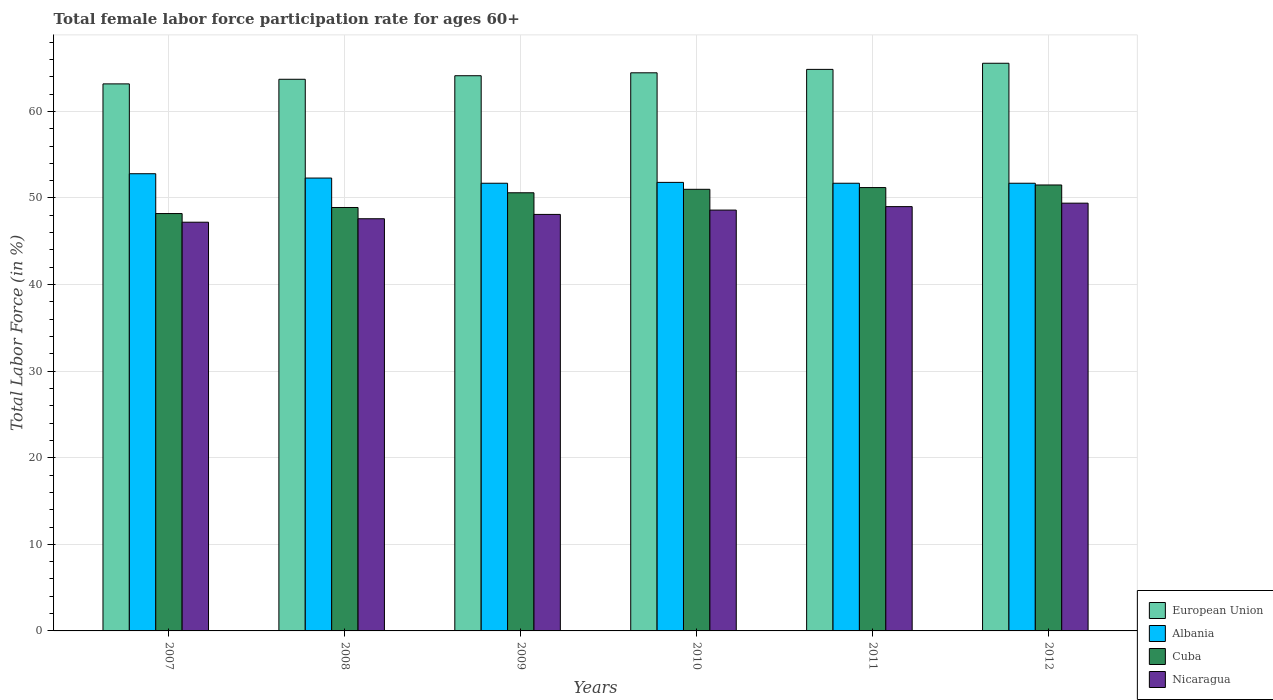Are the number of bars per tick equal to the number of legend labels?
Give a very brief answer. Yes. Are the number of bars on each tick of the X-axis equal?
Make the answer very short. Yes. How many bars are there on the 4th tick from the right?
Make the answer very short. 4. What is the label of the 1st group of bars from the left?
Your response must be concise. 2007. In how many cases, is the number of bars for a given year not equal to the number of legend labels?
Your answer should be compact. 0. What is the female labor force participation rate in Albania in 2009?
Ensure brevity in your answer.  51.7. Across all years, what is the maximum female labor force participation rate in Cuba?
Make the answer very short. 51.5. Across all years, what is the minimum female labor force participation rate in Albania?
Your answer should be compact. 51.7. In which year was the female labor force participation rate in Nicaragua maximum?
Give a very brief answer. 2012. What is the total female labor force participation rate in Nicaragua in the graph?
Provide a succinct answer. 289.9. What is the difference between the female labor force participation rate in Albania in 2008 and that in 2011?
Give a very brief answer. 0.6. What is the difference between the female labor force participation rate in Albania in 2007 and the female labor force participation rate in Cuba in 2008?
Your response must be concise. 3.9. What is the average female labor force participation rate in Cuba per year?
Offer a terse response. 50.23. In the year 2009, what is the difference between the female labor force participation rate in European Union and female labor force participation rate in Nicaragua?
Provide a succinct answer. 16.02. In how many years, is the female labor force participation rate in European Union greater than 28 %?
Offer a terse response. 6. What is the ratio of the female labor force participation rate in European Union in 2008 to that in 2011?
Offer a terse response. 0.98. Is the difference between the female labor force participation rate in European Union in 2010 and 2011 greater than the difference between the female labor force participation rate in Nicaragua in 2010 and 2011?
Make the answer very short. Yes. What is the difference between the highest and the second highest female labor force participation rate in Cuba?
Provide a succinct answer. 0.3. What is the difference between the highest and the lowest female labor force participation rate in Nicaragua?
Keep it short and to the point. 2.2. In how many years, is the female labor force participation rate in European Union greater than the average female labor force participation rate in European Union taken over all years?
Ensure brevity in your answer.  3. Is the sum of the female labor force participation rate in Albania in 2008 and 2012 greater than the maximum female labor force participation rate in European Union across all years?
Provide a short and direct response. Yes. Is it the case that in every year, the sum of the female labor force participation rate in Nicaragua and female labor force participation rate in Cuba is greater than the sum of female labor force participation rate in European Union and female labor force participation rate in Albania?
Your answer should be compact. No. What does the 1st bar from the left in 2007 represents?
Provide a succinct answer. European Union. Are all the bars in the graph horizontal?
Make the answer very short. No. How many years are there in the graph?
Make the answer very short. 6. Does the graph contain grids?
Your response must be concise. Yes. How are the legend labels stacked?
Provide a succinct answer. Vertical. What is the title of the graph?
Ensure brevity in your answer.  Total female labor force participation rate for ages 60+. Does "Bosnia and Herzegovina" appear as one of the legend labels in the graph?
Keep it short and to the point. No. What is the Total Labor Force (in %) of European Union in 2007?
Offer a terse response. 63.17. What is the Total Labor Force (in %) in Albania in 2007?
Provide a succinct answer. 52.8. What is the Total Labor Force (in %) of Cuba in 2007?
Your response must be concise. 48.2. What is the Total Labor Force (in %) in Nicaragua in 2007?
Provide a short and direct response. 47.2. What is the Total Labor Force (in %) of European Union in 2008?
Make the answer very short. 63.71. What is the Total Labor Force (in %) of Albania in 2008?
Give a very brief answer. 52.3. What is the Total Labor Force (in %) of Cuba in 2008?
Your answer should be very brief. 48.9. What is the Total Labor Force (in %) of Nicaragua in 2008?
Your response must be concise. 47.6. What is the Total Labor Force (in %) of European Union in 2009?
Offer a very short reply. 64.12. What is the Total Labor Force (in %) in Albania in 2009?
Provide a succinct answer. 51.7. What is the Total Labor Force (in %) in Cuba in 2009?
Ensure brevity in your answer.  50.6. What is the Total Labor Force (in %) of Nicaragua in 2009?
Your response must be concise. 48.1. What is the Total Labor Force (in %) of European Union in 2010?
Keep it short and to the point. 64.45. What is the Total Labor Force (in %) in Albania in 2010?
Your answer should be very brief. 51.8. What is the Total Labor Force (in %) of Nicaragua in 2010?
Make the answer very short. 48.6. What is the Total Labor Force (in %) of European Union in 2011?
Your answer should be very brief. 64.85. What is the Total Labor Force (in %) of Albania in 2011?
Give a very brief answer. 51.7. What is the Total Labor Force (in %) in Cuba in 2011?
Your answer should be very brief. 51.2. What is the Total Labor Force (in %) of Nicaragua in 2011?
Ensure brevity in your answer.  49. What is the Total Labor Force (in %) of European Union in 2012?
Keep it short and to the point. 65.56. What is the Total Labor Force (in %) in Albania in 2012?
Your answer should be compact. 51.7. What is the Total Labor Force (in %) in Cuba in 2012?
Give a very brief answer. 51.5. What is the Total Labor Force (in %) of Nicaragua in 2012?
Your response must be concise. 49.4. Across all years, what is the maximum Total Labor Force (in %) in European Union?
Your answer should be very brief. 65.56. Across all years, what is the maximum Total Labor Force (in %) in Albania?
Your response must be concise. 52.8. Across all years, what is the maximum Total Labor Force (in %) of Cuba?
Give a very brief answer. 51.5. Across all years, what is the maximum Total Labor Force (in %) in Nicaragua?
Ensure brevity in your answer.  49.4. Across all years, what is the minimum Total Labor Force (in %) in European Union?
Your answer should be very brief. 63.17. Across all years, what is the minimum Total Labor Force (in %) in Albania?
Offer a very short reply. 51.7. Across all years, what is the minimum Total Labor Force (in %) in Cuba?
Keep it short and to the point. 48.2. Across all years, what is the minimum Total Labor Force (in %) in Nicaragua?
Provide a short and direct response. 47.2. What is the total Total Labor Force (in %) of European Union in the graph?
Your answer should be compact. 385.86. What is the total Total Labor Force (in %) in Albania in the graph?
Your answer should be compact. 312. What is the total Total Labor Force (in %) of Cuba in the graph?
Provide a succinct answer. 301.4. What is the total Total Labor Force (in %) of Nicaragua in the graph?
Keep it short and to the point. 289.9. What is the difference between the Total Labor Force (in %) of European Union in 2007 and that in 2008?
Make the answer very short. -0.53. What is the difference between the Total Labor Force (in %) in Cuba in 2007 and that in 2008?
Your answer should be compact. -0.7. What is the difference between the Total Labor Force (in %) in Nicaragua in 2007 and that in 2008?
Ensure brevity in your answer.  -0.4. What is the difference between the Total Labor Force (in %) in European Union in 2007 and that in 2009?
Your response must be concise. -0.94. What is the difference between the Total Labor Force (in %) in Albania in 2007 and that in 2009?
Make the answer very short. 1.1. What is the difference between the Total Labor Force (in %) in Cuba in 2007 and that in 2009?
Offer a very short reply. -2.4. What is the difference between the Total Labor Force (in %) in Nicaragua in 2007 and that in 2009?
Give a very brief answer. -0.9. What is the difference between the Total Labor Force (in %) of European Union in 2007 and that in 2010?
Provide a short and direct response. -1.28. What is the difference between the Total Labor Force (in %) of Nicaragua in 2007 and that in 2010?
Ensure brevity in your answer.  -1.4. What is the difference between the Total Labor Force (in %) in European Union in 2007 and that in 2011?
Keep it short and to the point. -1.68. What is the difference between the Total Labor Force (in %) in Cuba in 2007 and that in 2011?
Offer a terse response. -3. What is the difference between the Total Labor Force (in %) of European Union in 2007 and that in 2012?
Your response must be concise. -2.38. What is the difference between the Total Labor Force (in %) in European Union in 2008 and that in 2009?
Ensure brevity in your answer.  -0.41. What is the difference between the Total Labor Force (in %) in Albania in 2008 and that in 2009?
Provide a short and direct response. 0.6. What is the difference between the Total Labor Force (in %) of Cuba in 2008 and that in 2009?
Your answer should be compact. -1.7. What is the difference between the Total Labor Force (in %) in European Union in 2008 and that in 2010?
Offer a very short reply. -0.75. What is the difference between the Total Labor Force (in %) of Nicaragua in 2008 and that in 2010?
Offer a terse response. -1. What is the difference between the Total Labor Force (in %) of European Union in 2008 and that in 2011?
Offer a terse response. -1.14. What is the difference between the Total Labor Force (in %) in Albania in 2008 and that in 2011?
Offer a terse response. 0.6. What is the difference between the Total Labor Force (in %) of European Union in 2008 and that in 2012?
Your answer should be very brief. -1.85. What is the difference between the Total Labor Force (in %) in Albania in 2008 and that in 2012?
Ensure brevity in your answer.  0.6. What is the difference between the Total Labor Force (in %) in Cuba in 2008 and that in 2012?
Provide a succinct answer. -2.6. What is the difference between the Total Labor Force (in %) in Nicaragua in 2008 and that in 2012?
Provide a short and direct response. -1.8. What is the difference between the Total Labor Force (in %) in European Union in 2009 and that in 2010?
Offer a very short reply. -0.34. What is the difference between the Total Labor Force (in %) in Cuba in 2009 and that in 2010?
Your response must be concise. -0.4. What is the difference between the Total Labor Force (in %) of Nicaragua in 2009 and that in 2010?
Provide a short and direct response. -0.5. What is the difference between the Total Labor Force (in %) of European Union in 2009 and that in 2011?
Offer a terse response. -0.73. What is the difference between the Total Labor Force (in %) in Cuba in 2009 and that in 2011?
Provide a short and direct response. -0.6. What is the difference between the Total Labor Force (in %) of Nicaragua in 2009 and that in 2011?
Provide a short and direct response. -0.9. What is the difference between the Total Labor Force (in %) in European Union in 2009 and that in 2012?
Offer a terse response. -1.44. What is the difference between the Total Labor Force (in %) of European Union in 2010 and that in 2011?
Your response must be concise. -0.39. What is the difference between the Total Labor Force (in %) of Albania in 2010 and that in 2011?
Offer a very short reply. 0.1. What is the difference between the Total Labor Force (in %) of European Union in 2010 and that in 2012?
Provide a succinct answer. -1.1. What is the difference between the Total Labor Force (in %) of Albania in 2010 and that in 2012?
Make the answer very short. 0.1. What is the difference between the Total Labor Force (in %) of European Union in 2011 and that in 2012?
Offer a very short reply. -0.71. What is the difference between the Total Labor Force (in %) in Albania in 2011 and that in 2012?
Ensure brevity in your answer.  0. What is the difference between the Total Labor Force (in %) in Cuba in 2011 and that in 2012?
Keep it short and to the point. -0.3. What is the difference between the Total Labor Force (in %) in European Union in 2007 and the Total Labor Force (in %) in Albania in 2008?
Keep it short and to the point. 10.87. What is the difference between the Total Labor Force (in %) of European Union in 2007 and the Total Labor Force (in %) of Cuba in 2008?
Keep it short and to the point. 14.27. What is the difference between the Total Labor Force (in %) in European Union in 2007 and the Total Labor Force (in %) in Nicaragua in 2008?
Keep it short and to the point. 15.57. What is the difference between the Total Labor Force (in %) in Cuba in 2007 and the Total Labor Force (in %) in Nicaragua in 2008?
Provide a succinct answer. 0.6. What is the difference between the Total Labor Force (in %) in European Union in 2007 and the Total Labor Force (in %) in Albania in 2009?
Your answer should be compact. 11.47. What is the difference between the Total Labor Force (in %) in European Union in 2007 and the Total Labor Force (in %) in Cuba in 2009?
Offer a terse response. 12.57. What is the difference between the Total Labor Force (in %) in European Union in 2007 and the Total Labor Force (in %) in Nicaragua in 2009?
Ensure brevity in your answer.  15.07. What is the difference between the Total Labor Force (in %) in Albania in 2007 and the Total Labor Force (in %) in Nicaragua in 2009?
Offer a very short reply. 4.7. What is the difference between the Total Labor Force (in %) of Cuba in 2007 and the Total Labor Force (in %) of Nicaragua in 2009?
Provide a short and direct response. 0.1. What is the difference between the Total Labor Force (in %) in European Union in 2007 and the Total Labor Force (in %) in Albania in 2010?
Your answer should be very brief. 11.37. What is the difference between the Total Labor Force (in %) in European Union in 2007 and the Total Labor Force (in %) in Cuba in 2010?
Your response must be concise. 12.17. What is the difference between the Total Labor Force (in %) of European Union in 2007 and the Total Labor Force (in %) of Nicaragua in 2010?
Offer a very short reply. 14.57. What is the difference between the Total Labor Force (in %) in Cuba in 2007 and the Total Labor Force (in %) in Nicaragua in 2010?
Give a very brief answer. -0.4. What is the difference between the Total Labor Force (in %) in European Union in 2007 and the Total Labor Force (in %) in Albania in 2011?
Keep it short and to the point. 11.47. What is the difference between the Total Labor Force (in %) in European Union in 2007 and the Total Labor Force (in %) in Cuba in 2011?
Offer a terse response. 11.97. What is the difference between the Total Labor Force (in %) in European Union in 2007 and the Total Labor Force (in %) in Nicaragua in 2011?
Offer a terse response. 14.17. What is the difference between the Total Labor Force (in %) of Albania in 2007 and the Total Labor Force (in %) of Nicaragua in 2011?
Provide a short and direct response. 3.8. What is the difference between the Total Labor Force (in %) of Cuba in 2007 and the Total Labor Force (in %) of Nicaragua in 2011?
Ensure brevity in your answer.  -0.8. What is the difference between the Total Labor Force (in %) in European Union in 2007 and the Total Labor Force (in %) in Albania in 2012?
Make the answer very short. 11.47. What is the difference between the Total Labor Force (in %) of European Union in 2007 and the Total Labor Force (in %) of Cuba in 2012?
Provide a succinct answer. 11.67. What is the difference between the Total Labor Force (in %) in European Union in 2007 and the Total Labor Force (in %) in Nicaragua in 2012?
Provide a short and direct response. 13.77. What is the difference between the Total Labor Force (in %) of Albania in 2007 and the Total Labor Force (in %) of Cuba in 2012?
Offer a terse response. 1.3. What is the difference between the Total Labor Force (in %) of Albania in 2007 and the Total Labor Force (in %) of Nicaragua in 2012?
Make the answer very short. 3.4. What is the difference between the Total Labor Force (in %) in European Union in 2008 and the Total Labor Force (in %) in Albania in 2009?
Keep it short and to the point. 12.01. What is the difference between the Total Labor Force (in %) of European Union in 2008 and the Total Labor Force (in %) of Cuba in 2009?
Provide a short and direct response. 13.11. What is the difference between the Total Labor Force (in %) in European Union in 2008 and the Total Labor Force (in %) in Nicaragua in 2009?
Offer a very short reply. 15.61. What is the difference between the Total Labor Force (in %) of Albania in 2008 and the Total Labor Force (in %) of Cuba in 2009?
Make the answer very short. 1.7. What is the difference between the Total Labor Force (in %) of Albania in 2008 and the Total Labor Force (in %) of Nicaragua in 2009?
Your answer should be compact. 4.2. What is the difference between the Total Labor Force (in %) of Cuba in 2008 and the Total Labor Force (in %) of Nicaragua in 2009?
Your answer should be very brief. 0.8. What is the difference between the Total Labor Force (in %) of European Union in 2008 and the Total Labor Force (in %) of Albania in 2010?
Your answer should be compact. 11.91. What is the difference between the Total Labor Force (in %) in European Union in 2008 and the Total Labor Force (in %) in Cuba in 2010?
Offer a very short reply. 12.71. What is the difference between the Total Labor Force (in %) in European Union in 2008 and the Total Labor Force (in %) in Nicaragua in 2010?
Offer a very short reply. 15.11. What is the difference between the Total Labor Force (in %) of European Union in 2008 and the Total Labor Force (in %) of Albania in 2011?
Give a very brief answer. 12.01. What is the difference between the Total Labor Force (in %) of European Union in 2008 and the Total Labor Force (in %) of Cuba in 2011?
Your answer should be compact. 12.51. What is the difference between the Total Labor Force (in %) in European Union in 2008 and the Total Labor Force (in %) in Nicaragua in 2011?
Your answer should be very brief. 14.71. What is the difference between the Total Labor Force (in %) in Albania in 2008 and the Total Labor Force (in %) in Nicaragua in 2011?
Your response must be concise. 3.3. What is the difference between the Total Labor Force (in %) of Cuba in 2008 and the Total Labor Force (in %) of Nicaragua in 2011?
Offer a very short reply. -0.1. What is the difference between the Total Labor Force (in %) in European Union in 2008 and the Total Labor Force (in %) in Albania in 2012?
Make the answer very short. 12.01. What is the difference between the Total Labor Force (in %) of European Union in 2008 and the Total Labor Force (in %) of Cuba in 2012?
Provide a short and direct response. 12.21. What is the difference between the Total Labor Force (in %) of European Union in 2008 and the Total Labor Force (in %) of Nicaragua in 2012?
Provide a succinct answer. 14.31. What is the difference between the Total Labor Force (in %) of Albania in 2008 and the Total Labor Force (in %) of Cuba in 2012?
Give a very brief answer. 0.8. What is the difference between the Total Labor Force (in %) of Albania in 2008 and the Total Labor Force (in %) of Nicaragua in 2012?
Offer a terse response. 2.9. What is the difference between the Total Labor Force (in %) of Cuba in 2008 and the Total Labor Force (in %) of Nicaragua in 2012?
Your answer should be very brief. -0.5. What is the difference between the Total Labor Force (in %) of European Union in 2009 and the Total Labor Force (in %) of Albania in 2010?
Keep it short and to the point. 12.32. What is the difference between the Total Labor Force (in %) in European Union in 2009 and the Total Labor Force (in %) in Cuba in 2010?
Provide a succinct answer. 13.12. What is the difference between the Total Labor Force (in %) of European Union in 2009 and the Total Labor Force (in %) of Nicaragua in 2010?
Your answer should be very brief. 15.52. What is the difference between the Total Labor Force (in %) of European Union in 2009 and the Total Labor Force (in %) of Albania in 2011?
Your answer should be very brief. 12.42. What is the difference between the Total Labor Force (in %) of European Union in 2009 and the Total Labor Force (in %) of Cuba in 2011?
Provide a succinct answer. 12.92. What is the difference between the Total Labor Force (in %) in European Union in 2009 and the Total Labor Force (in %) in Nicaragua in 2011?
Provide a short and direct response. 15.12. What is the difference between the Total Labor Force (in %) of Albania in 2009 and the Total Labor Force (in %) of Cuba in 2011?
Provide a succinct answer. 0.5. What is the difference between the Total Labor Force (in %) of European Union in 2009 and the Total Labor Force (in %) of Albania in 2012?
Offer a terse response. 12.42. What is the difference between the Total Labor Force (in %) in European Union in 2009 and the Total Labor Force (in %) in Cuba in 2012?
Your answer should be compact. 12.62. What is the difference between the Total Labor Force (in %) of European Union in 2009 and the Total Labor Force (in %) of Nicaragua in 2012?
Provide a succinct answer. 14.72. What is the difference between the Total Labor Force (in %) of Albania in 2009 and the Total Labor Force (in %) of Nicaragua in 2012?
Your answer should be compact. 2.3. What is the difference between the Total Labor Force (in %) of Cuba in 2009 and the Total Labor Force (in %) of Nicaragua in 2012?
Offer a very short reply. 1.2. What is the difference between the Total Labor Force (in %) in European Union in 2010 and the Total Labor Force (in %) in Albania in 2011?
Your response must be concise. 12.75. What is the difference between the Total Labor Force (in %) in European Union in 2010 and the Total Labor Force (in %) in Cuba in 2011?
Keep it short and to the point. 13.25. What is the difference between the Total Labor Force (in %) in European Union in 2010 and the Total Labor Force (in %) in Nicaragua in 2011?
Offer a terse response. 15.45. What is the difference between the Total Labor Force (in %) in Albania in 2010 and the Total Labor Force (in %) in Cuba in 2011?
Provide a short and direct response. 0.6. What is the difference between the Total Labor Force (in %) in Albania in 2010 and the Total Labor Force (in %) in Nicaragua in 2011?
Offer a very short reply. 2.8. What is the difference between the Total Labor Force (in %) of European Union in 2010 and the Total Labor Force (in %) of Albania in 2012?
Provide a succinct answer. 12.75. What is the difference between the Total Labor Force (in %) in European Union in 2010 and the Total Labor Force (in %) in Cuba in 2012?
Give a very brief answer. 12.95. What is the difference between the Total Labor Force (in %) of European Union in 2010 and the Total Labor Force (in %) of Nicaragua in 2012?
Your answer should be very brief. 15.05. What is the difference between the Total Labor Force (in %) in European Union in 2011 and the Total Labor Force (in %) in Albania in 2012?
Give a very brief answer. 13.15. What is the difference between the Total Labor Force (in %) of European Union in 2011 and the Total Labor Force (in %) of Cuba in 2012?
Your response must be concise. 13.35. What is the difference between the Total Labor Force (in %) of European Union in 2011 and the Total Labor Force (in %) of Nicaragua in 2012?
Make the answer very short. 15.45. What is the difference between the Total Labor Force (in %) of Albania in 2011 and the Total Labor Force (in %) of Cuba in 2012?
Offer a terse response. 0.2. What is the difference between the Total Labor Force (in %) of Albania in 2011 and the Total Labor Force (in %) of Nicaragua in 2012?
Keep it short and to the point. 2.3. What is the average Total Labor Force (in %) in European Union per year?
Ensure brevity in your answer.  64.31. What is the average Total Labor Force (in %) in Cuba per year?
Provide a succinct answer. 50.23. What is the average Total Labor Force (in %) in Nicaragua per year?
Offer a terse response. 48.32. In the year 2007, what is the difference between the Total Labor Force (in %) of European Union and Total Labor Force (in %) of Albania?
Offer a very short reply. 10.37. In the year 2007, what is the difference between the Total Labor Force (in %) in European Union and Total Labor Force (in %) in Cuba?
Offer a very short reply. 14.97. In the year 2007, what is the difference between the Total Labor Force (in %) of European Union and Total Labor Force (in %) of Nicaragua?
Your answer should be compact. 15.97. In the year 2007, what is the difference between the Total Labor Force (in %) in Cuba and Total Labor Force (in %) in Nicaragua?
Provide a short and direct response. 1. In the year 2008, what is the difference between the Total Labor Force (in %) of European Union and Total Labor Force (in %) of Albania?
Offer a very short reply. 11.41. In the year 2008, what is the difference between the Total Labor Force (in %) of European Union and Total Labor Force (in %) of Cuba?
Keep it short and to the point. 14.81. In the year 2008, what is the difference between the Total Labor Force (in %) in European Union and Total Labor Force (in %) in Nicaragua?
Provide a succinct answer. 16.11. In the year 2008, what is the difference between the Total Labor Force (in %) of Albania and Total Labor Force (in %) of Nicaragua?
Your response must be concise. 4.7. In the year 2008, what is the difference between the Total Labor Force (in %) in Cuba and Total Labor Force (in %) in Nicaragua?
Provide a succinct answer. 1.3. In the year 2009, what is the difference between the Total Labor Force (in %) in European Union and Total Labor Force (in %) in Albania?
Provide a succinct answer. 12.42. In the year 2009, what is the difference between the Total Labor Force (in %) in European Union and Total Labor Force (in %) in Cuba?
Your response must be concise. 13.52. In the year 2009, what is the difference between the Total Labor Force (in %) of European Union and Total Labor Force (in %) of Nicaragua?
Provide a short and direct response. 16.02. In the year 2009, what is the difference between the Total Labor Force (in %) in Albania and Total Labor Force (in %) in Cuba?
Make the answer very short. 1.1. In the year 2009, what is the difference between the Total Labor Force (in %) in Albania and Total Labor Force (in %) in Nicaragua?
Provide a short and direct response. 3.6. In the year 2009, what is the difference between the Total Labor Force (in %) in Cuba and Total Labor Force (in %) in Nicaragua?
Offer a terse response. 2.5. In the year 2010, what is the difference between the Total Labor Force (in %) in European Union and Total Labor Force (in %) in Albania?
Offer a very short reply. 12.65. In the year 2010, what is the difference between the Total Labor Force (in %) of European Union and Total Labor Force (in %) of Cuba?
Provide a short and direct response. 13.45. In the year 2010, what is the difference between the Total Labor Force (in %) in European Union and Total Labor Force (in %) in Nicaragua?
Give a very brief answer. 15.85. In the year 2011, what is the difference between the Total Labor Force (in %) in European Union and Total Labor Force (in %) in Albania?
Keep it short and to the point. 13.15. In the year 2011, what is the difference between the Total Labor Force (in %) in European Union and Total Labor Force (in %) in Cuba?
Your response must be concise. 13.65. In the year 2011, what is the difference between the Total Labor Force (in %) of European Union and Total Labor Force (in %) of Nicaragua?
Provide a succinct answer. 15.85. In the year 2011, what is the difference between the Total Labor Force (in %) of Albania and Total Labor Force (in %) of Nicaragua?
Ensure brevity in your answer.  2.7. In the year 2011, what is the difference between the Total Labor Force (in %) of Cuba and Total Labor Force (in %) of Nicaragua?
Keep it short and to the point. 2.2. In the year 2012, what is the difference between the Total Labor Force (in %) of European Union and Total Labor Force (in %) of Albania?
Keep it short and to the point. 13.86. In the year 2012, what is the difference between the Total Labor Force (in %) of European Union and Total Labor Force (in %) of Cuba?
Give a very brief answer. 14.06. In the year 2012, what is the difference between the Total Labor Force (in %) of European Union and Total Labor Force (in %) of Nicaragua?
Keep it short and to the point. 16.16. In the year 2012, what is the difference between the Total Labor Force (in %) in Albania and Total Labor Force (in %) in Cuba?
Ensure brevity in your answer.  0.2. In the year 2012, what is the difference between the Total Labor Force (in %) in Albania and Total Labor Force (in %) in Nicaragua?
Offer a very short reply. 2.3. What is the ratio of the Total Labor Force (in %) in European Union in 2007 to that in 2008?
Your answer should be very brief. 0.99. What is the ratio of the Total Labor Force (in %) in Albania in 2007 to that in 2008?
Your response must be concise. 1.01. What is the ratio of the Total Labor Force (in %) of Cuba in 2007 to that in 2008?
Provide a succinct answer. 0.99. What is the ratio of the Total Labor Force (in %) of European Union in 2007 to that in 2009?
Ensure brevity in your answer.  0.99. What is the ratio of the Total Labor Force (in %) of Albania in 2007 to that in 2009?
Your answer should be very brief. 1.02. What is the ratio of the Total Labor Force (in %) of Cuba in 2007 to that in 2009?
Provide a succinct answer. 0.95. What is the ratio of the Total Labor Force (in %) of Nicaragua in 2007 to that in 2009?
Your answer should be compact. 0.98. What is the ratio of the Total Labor Force (in %) of European Union in 2007 to that in 2010?
Provide a short and direct response. 0.98. What is the ratio of the Total Labor Force (in %) in Albania in 2007 to that in 2010?
Offer a very short reply. 1.02. What is the ratio of the Total Labor Force (in %) of Cuba in 2007 to that in 2010?
Offer a very short reply. 0.95. What is the ratio of the Total Labor Force (in %) of Nicaragua in 2007 to that in 2010?
Provide a succinct answer. 0.97. What is the ratio of the Total Labor Force (in %) of European Union in 2007 to that in 2011?
Keep it short and to the point. 0.97. What is the ratio of the Total Labor Force (in %) of Albania in 2007 to that in 2011?
Give a very brief answer. 1.02. What is the ratio of the Total Labor Force (in %) in Cuba in 2007 to that in 2011?
Ensure brevity in your answer.  0.94. What is the ratio of the Total Labor Force (in %) in Nicaragua in 2007 to that in 2011?
Offer a very short reply. 0.96. What is the ratio of the Total Labor Force (in %) of European Union in 2007 to that in 2012?
Your answer should be compact. 0.96. What is the ratio of the Total Labor Force (in %) in Albania in 2007 to that in 2012?
Your answer should be compact. 1.02. What is the ratio of the Total Labor Force (in %) in Cuba in 2007 to that in 2012?
Offer a terse response. 0.94. What is the ratio of the Total Labor Force (in %) of Nicaragua in 2007 to that in 2012?
Offer a very short reply. 0.96. What is the ratio of the Total Labor Force (in %) in European Union in 2008 to that in 2009?
Provide a succinct answer. 0.99. What is the ratio of the Total Labor Force (in %) of Albania in 2008 to that in 2009?
Offer a terse response. 1.01. What is the ratio of the Total Labor Force (in %) in Cuba in 2008 to that in 2009?
Ensure brevity in your answer.  0.97. What is the ratio of the Total Labor Force (in %) in Nicaragua in 2008 to that in 2009?
Provide a short and direct response. 0.99. What is the ratio of the Total Labor Force (in %) of European Union in 2008 to that in 2010?
Keep it short and to the point. 0.99. What is the ratio of the Total Labor Force (in %) of Albania in 2008 to that in 2010?
Provide a succinct answer. 1.01. What is the ratio of the Total Labor Force (in %) of Cuba in 2008 to that in 2010?
Your response must be concise. 0.96. What is the ratio of the Total Labor Force (in %) of Nicaragua in 2008 to that in 2010?
Make the answer very short. 0.98. What is the ratio of the Total Labor Force (in %) of European Union in 2008 to that in 2011?
Provide a succinct answer. 0.98. What is the ratio of the Total Labor Force (in %) of Albania in 2008 to that in 2011?
Give a very brief answer. 1.01. What is the ratio of the Total Labor Force (in %) in Cuba in 2008 to that in 2011?
Give a very brief answer. 0.96. What is the ratio of the Total Labor Force (in %) of Nicaragua in 2008 to that in 2011?
Offer a terse response. 0.97. What is the ratio of the Total Labor Force (in %) in European Union in 2008 to that in 2012?
Your answer should be compact. 0.97. What is the ratio of the Total Labor Force (in %) in Albania in 2008 to that in 2012?
Make the answer very short. 1.01. What is the ratio of the Total Labor Force (in %) of Cuba in 2008 to that in 2012?
Your answer should be compact. 0.95. What is the ratio of the Total Labor Force (in %) in Nicaragua in 2008 to that in 2012?
Make the answer very short. 0.96. What is the ratio of the Total Labor Force (in %) in Albania in 2009 to that in 2010?
Make the answer very short. 1. What is the ratio of the Total Labor Force (in %) in Cuba in 2009 to that in 2010?
Keep it short and to the point. 0.99. What is the ratio of the Total Labor Force (in %) in European Union in 2009 to that in 2011?
Your answer should be very brief. 0.99. What is the ratio of the Total Labor Force (in %) in Cuba in 2009 to that in 2011?
Give a very brief answer. 0.99. What is the ratio of the Total Labor Force (in %) of Nicaragua in 2009 to that in 2011?
Your response must be concise. 0.98. What is the ratio of the Total Labor Force (in %) in European Union in 2009 to that in 2012?
Offer a very short reply. 0.98. What is the ratio of the Total Labor Force (in %) of Albania in 2009 to that in 2012?
Provide a succinct answer. 1. What is the ratio of the Total Labor Force (in %) of Cuba in 2009 to that in 2012?
Your answer should be compact. 0.98. What is the ratio of the Total Labor Force (in %) of Nicaragua in 2009 to that in 2012?
Your answer should be compact. 0.97. What is the ratio of the Total Labor Force (in %) of European Union in 2010 to that in 2011?
Make the answer very short. 0.99. What is the ratio of the Total Labor Force (in %) in Albania in 2010 to that in 2011?
Ensure brevity in your answer.  1. What is the ratio of the Total Labor Force (in %) of Cuba in 2010 to that in 2011?
Provide a succinct answer. 1. What is the ratio of the Total Labor Force (in %) of European Union in 2010 to that in 2012?
Ensure brevity in your answer.  0.98. What is the ratio of the Total Labor Force (in %) in Cuba in 2010 to that in 2012?
Keep it short and to the point. 0.99. What is the ratio of the Total Labor Force (in %) of Nicaragua in 2010 to that in 2012?
Offer a very short reply. 0.98. What is the ratio of the Total Labor Force (in %) of Albania in 2011 to that in 2012?
Make the answer very short. 1. What is the ratio of the Total Labor Force (in %) of Cuba in 2011 to that in 2012?
Offer a very short reply. 0.99. What is the ratio of the Total Labor Force (in %) in Nicaragua in 2011 to that in 2012?
Ensure brevity in your answer.  0.99. What is the difference between the highest and the second highest Total Labor Force (in %) in European Union?
Offer a terse response. 0.71. What is the difference between the highest and the second highest Total Labor Force (in %) in Cuba?
Make the answer very short. 0.3. What is the difference between the highest and the lowest Total Labor Force (in %) of European Union?
Offer a terse response. 2.38. What is the difference between the highest and the lowest Total Labor Force (in %) in Cuba?
Offer a terse response. 3.3. 